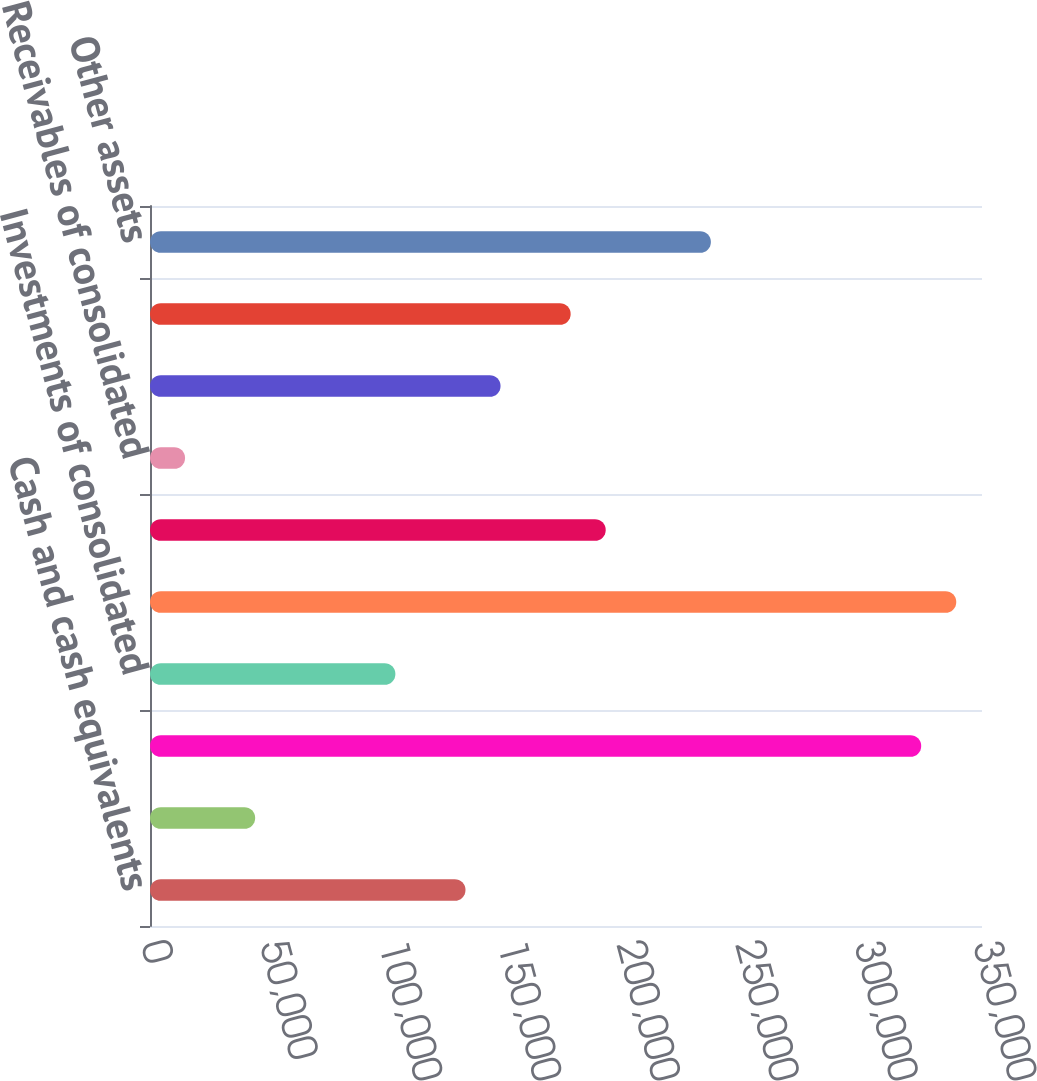Convert chart to OTSL. <chart><loc_0><loc_0><loc_500><loc_500><bar_chart><fcel>Cash and cash equivalents<fcel>Cash of consolidated<fcel>Investments<fcel>Investments of consolidated<fcel>Separate account assets<fcel>Receivables<fcel>Receivables of consolidated<fcel>Deferred acquisition costs<fcel>Restricted and segregated cash<fcel>Other assets<nl><fcel>132723<fcel>44243.1<fcel>324430<fcel>103230<fcel>339177<fcel>191710<fcel>14749.7<fcel>147470<fcel>176963<fcel>235950<nl></chart> 